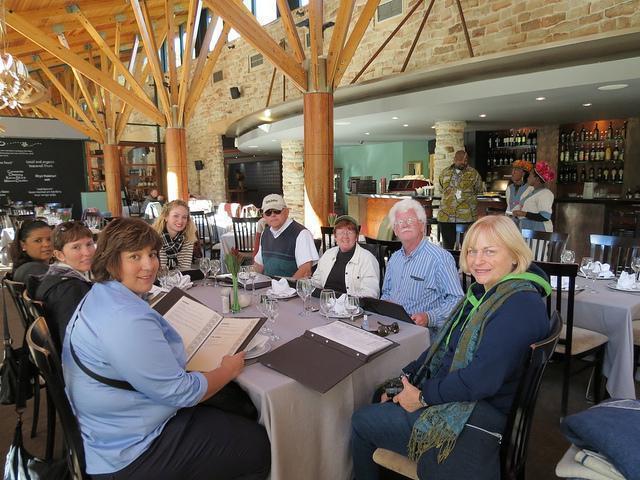What will persons seated here do next?
Indicate the correct response by choosing from the four available options to answer the question.
Options: Order, sing, pay, leave. Order. 